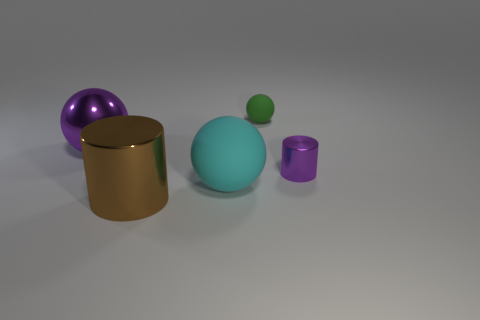Add 1 rubber objects. How many objects exist? 6 Subtract all big shiny spheres. How many spheres are left? 2 Subtract 1 cylinders. How many cylinders are left? 1 Subtract all gray cylinders. How many cyan spheres are left? 1 Subtract all spheres. Subtract all big red matte objects. How many objects are left? 2 Add 3 small metallic objects. How many small metallic objects are left? 4 Add 3 small purple things. How many small purple things exist? 4 Subtract all purple balls. How many balls are left? 2 Subtract 1 cyan spheres. How many objects are left? 4 Subtract all balls. How many objects are left? 2 